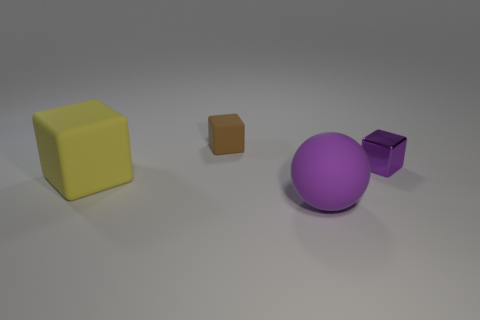Subtract all tiny blocks. How many blocks are left? 1 Add 1 small green metal cylinders. How many objects exist? 5 Subtract all brown cubes. How many cubes are left? 2 Subtract all spheres. How many objects are left? 3 Subtract all tiny blocks. Subtract all tiny things. How many objects are left? 0 Add 3 big purple things. How many big purple things are left? 4 Add 1 large purple rubber spheres. How many large purple rubber spheres exist? 2 Subtract 0 red blocks. How many objects are left? 4 Subtract all brown blocks. Subtract all gray balls. How many blocks are left? 2 